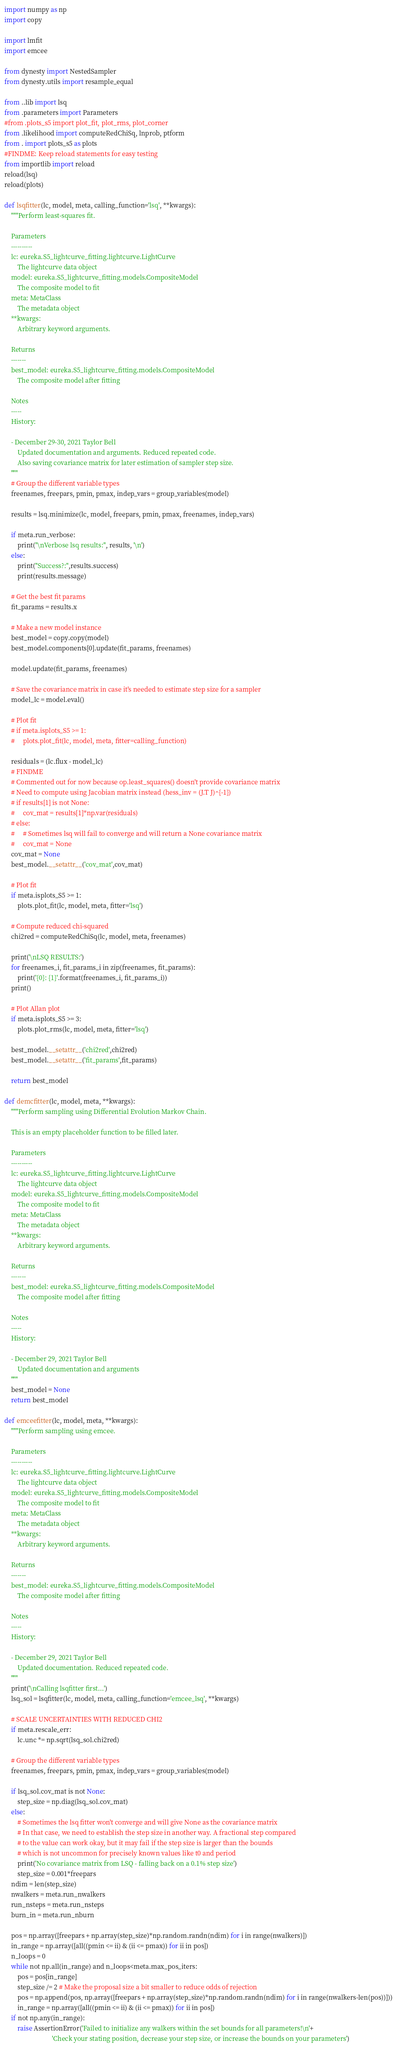<code> <loc_0><loc_0><loc_500><loc_500><_Python_>import numpy as np
import copy

import lmfit
import emcee

from dynesty import NestedSampler
from dynesty.utils import resample_equal

from ..lib import lsq
from .parameters import Parameters
#from .plots_s5 import plot_fit, plot_rms, plot_corner
from .likelihood import computeRedChiSq, lnprob, ptform
from . import plots_s5 as plots
#FINDME: Keep reload statements for easy testing
from importlib import reload
reload(lsq)
reload(plots)

def lsqfitter(lc, model, meta, calling_function='lsq', **kwargs):
    """Perform least-squares fit.

    Parameters
    ----------
    lc: eureka.S5_lightcurve_fitting.lightcurve.LightCurve
        The lightcurve data object
    model: eureka.S5_lightcurve_fitting.models.CompositeModel
        The composite model to fit
    meta: MetaClass
        The metadata object
    **kwargs:
        Arbitrary keyword arguments.

    Returns
    -------
    best_model: eureka.S5_lightcurve_fitting.models.CompositeModel
        The composite model after fitting

    Notes
    -----
    History:

    - December 29-30, 2021 Taylor Bell
        Updated documentation and arguments. Reduced repeated code.
        Also saving covariance matrix for later estimation of sampler step size.
    """
    # Group the different variable types
    freenames, freepars, pmin, pmax, indep_vars = group_variables(model)

    results = lsq.minimize(lc, model, freepars, pmin, pmax, freenames, indep_vars)

    if meta.run_verbose:
        print("\nVerbose lsq results:", results, '\n')
    else:
        print("Success?:",results.success)
        print(results.message)

    # Get the best fit params
    fit_params = results.x

    # Make a new model instance
    best_model = copy.copy(model)
    best_model.components[0].update(fit_params, freenames)

    model.update(fit_params, freenames)

    # Save the covariance matrix in case it's needed to estimate step size for a sampler
    model_lc = model.eval()

    # Plot fit
    # if meta.isplots_S5 >= 1:
    #     plots.plot_fit(lc, model, meta, fitter=calling_function)

    residuals = (lc.flux - model_lc)
    # FINDME
    # Commented out for now because op.least_squares() doesn't provide covariance matrix
    # Need to compute using Jacobian matrix instead (hess_inv = (J.T J)^{-1})
    # if results[1] is not None:
    #     cov_mat = results[1]*np.var(residuals)
    # else:
    #     # Sometimes lsq will fail to converge and will return a None covariance matrix
    #     cov_mat = None
    cov_mat = None
    best_model.__setattr__('cov_mat',cov_mat)

    # Plot fit
    if meta.isplots_S5 >= 1:
        plots.plot_fit(lc, model, meta, fitter='lsq')

    # Compute reduced chi-squared
    chi2red = computeRedChiSq(lc, model, meta, freenames)

    print('\nLSQ RESULTS:')
    for freenames_i, fit_params_i in zip(freenames, fit_params):
        print('{0}: {1}'.format(freenames_i, fit_params_i))
    print()

    # Plot Allan plot
    if meta.isplots_S5 >= 3:
        plots.plot_rms(lc, model, meta, fitter='lsq')

    best_model.__setattr__('chi2red',chi2red)
    best_model.__setattr__('fit_params',fit_params)

    return best_model

def demcfitter(lc, model, meta, **kwargs):
    """Perform sampling using Differential Evolution Markov Chain.

    This is an empty placeholder function to be filled later.

    Parameters
    ----------
    lc: eureka.S5_lightcurve_fitting.lightcurve.LightCurve
        The lightcurve data object
    model: eureka.S5_lightcurve_fitting.models.CompositeModel
        The composite model to fit
    meta: MetaClass
        The metadata object
    **kwargs:
        Arbitrary keyword arguments.

    Returns
    -------
    best_model: eureka.S5_lightcurve_fitting.models.CompositeModel
        The composite model after fitting

    Notes
    -----
    History:

    - December 29, 2021 Taylor Bell
        Updated documentation and arguments
    """
    best_model = None
    return best_model

def emceefitter(lc, model, meta, **kwargs):
    """Perform sampling using emcee.

    Parameters
    ----------
    lc: eureka.S5_lightcurve_fitting.lightcurve.LightCurve
        The lightcurve data object
    model: eureka.S5_lightcurve_fitting.models.CompositeModel
        The composite model to fit
    meta: MetaClass
        The metadata object
    **kwargs:
        Arbitrary keyword arguments.

    Returns
    -------
    best_model: eureka.S5_lightcurve_fitting.models.CompositeModel
        The composite model after fitting

    Notes
    -----
    History:

    - December 29, 2021 Taylor Bell
        Updated documentation. Reduced repeated code.
    """
    print('\nCalling lsqfitter first...')
    lsq_sol = lsqfitter(lc, model, meta, calling_function='emcee_lsq', **kwargs)

    # SCALE UNCERTAINTIES WITH REDUCED CHI2
    if meta.rescale_err:
        lc.unc *= np.sqrt(lsq_sol.chi2red)

    # Group the different variable types
    freenames, freepars, pmin, pmax, indep_vars = group_variables(model)

    if lsq_sol.cov_mat is not None:
        step_size = np.diag(lsq_sol.cov_mat)
    else:
        # Sometimes the lsq fitter won't converge and will give None as the covariance matrix
        # In that case, we need to establish the step size in another way. A fractional step compared
        # to the value can work okay, but it may fail if the step size is larger than the bounds
        # which is not uncommon for precisely known values like t0 and period
        print('No covariance matrix from LSQ - falling back on a 0.1% step size')
        step_size = 0.001*freepars
    ndim = len(step_size)
    nwalkers = meta.run_nwalkers
    run_nsteps = meta.run_nsteps
    burn_in = meta.run_nburn

    pos = np.array([freepars + np.array(step_size)*np.random.randn(ndim) for i in range(nwalkers)])
    in_range = np.array([all((pmin <= ii) & (ii <= pmax)) for ii in pos])
    n_loops = 0
    while not np.all(in_range) and n_loops<meta.max_pos_iters:
        pos = pos[in_range]
        step_size /= 2 # Make the proposal size a bit smaller to reduce odds of rejection
        pos = np.append(pos, np.array([freepars + np.array(step_size)*np.random.randn(ndim) for i in range(nwalkers-len(pos))]))
        in_range = np.array([all((pmin <= ii) & (ii <= pmax)) for ii in pos])
    if not np.any(in_range):
        raise AssertionError('Failed to initialize any walkers within the set bounds for all parameters!\n'+
                             'Check your stating position, decrease your step size, or increase the bounds on your parameters')</code> 